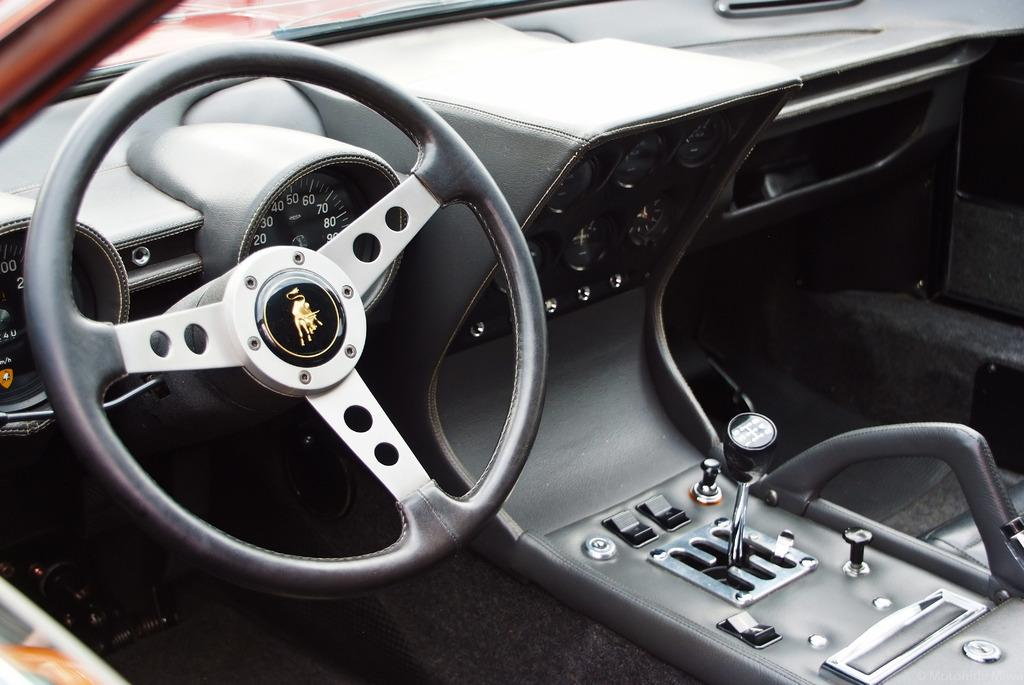What type of vehicle is the inside view of in the image? The image is an inside view of a car. Where is the steering wheel located in the image? The steering wheel is on the left side of the image. What is the purpose of the gearing system visible in the image? The gearing system is used for changing gears while driving the car. What type of produce is being harvested in the image? There is no produce present in the image; it is an inside view of a car. What invention is being demonstrated in the image? The image does not demonstrate any specific invention; it is a view of a car's interior. 